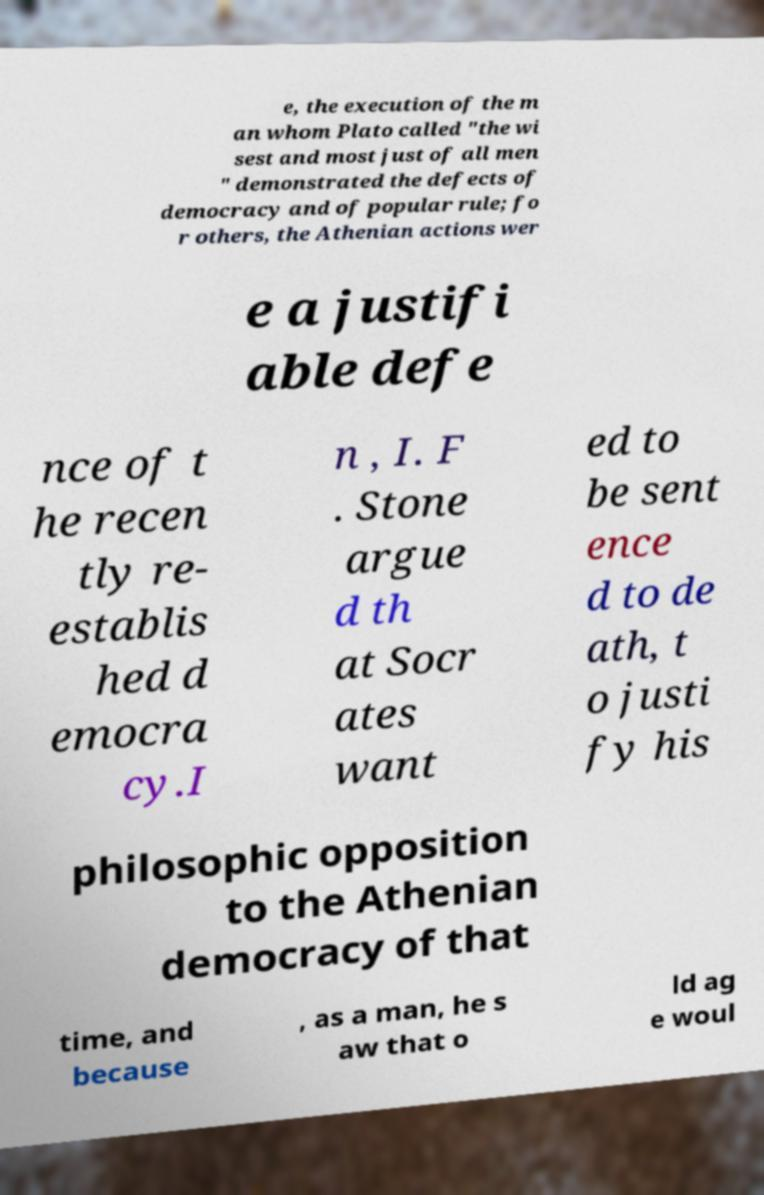Please read and relay the text visible in this image. What does it say? e, the execution of the m an whom Plato called "the wi sest and most just of all men " demonstrated the defects of democracy and of popular rule; fo r others, the Athenian actions wer e a justifi able defe nce of t he recen tly re- establis hed d emocra cy.I n , I. F . Stone argue d th at Socr ates want ed to be sent ence d to de ath, t o justi fy his philosophic opposition to the Athenian democracy of that time, and because , as a man, he s aw that o ld ag e woul 